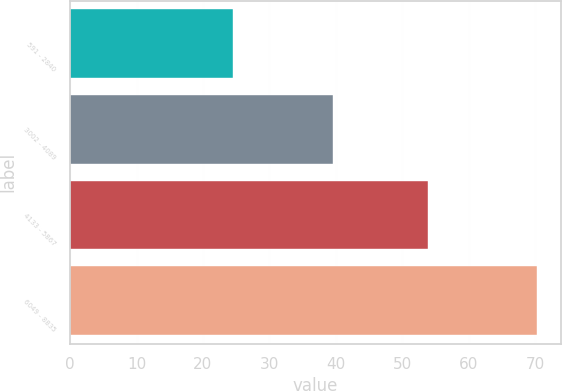Convert chart. <chart><loc_0><loc_0><loc_500><loc_500><bar_chart><fcel>591 - 2840<fcel>3002 - 4089<fcel>4133 - 5867<fcel>6049 - 8835<nl><fcel>24.51<fcel>39.6<fcel>53.92<fcel>70.37<nl></chart> 